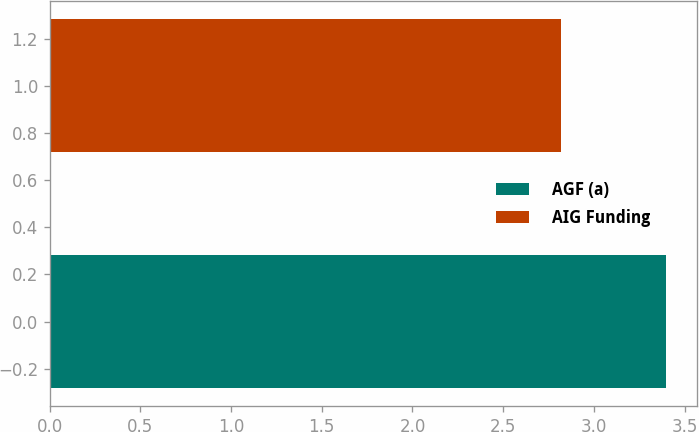Convert chart. <chart><loc_0><loc_0><loc_500><loc_500><bar_chart><fcel>AGF (a)<fcel>AIG Funding<nl><fcel>3.4<fcel>2.82<nl></chart> 